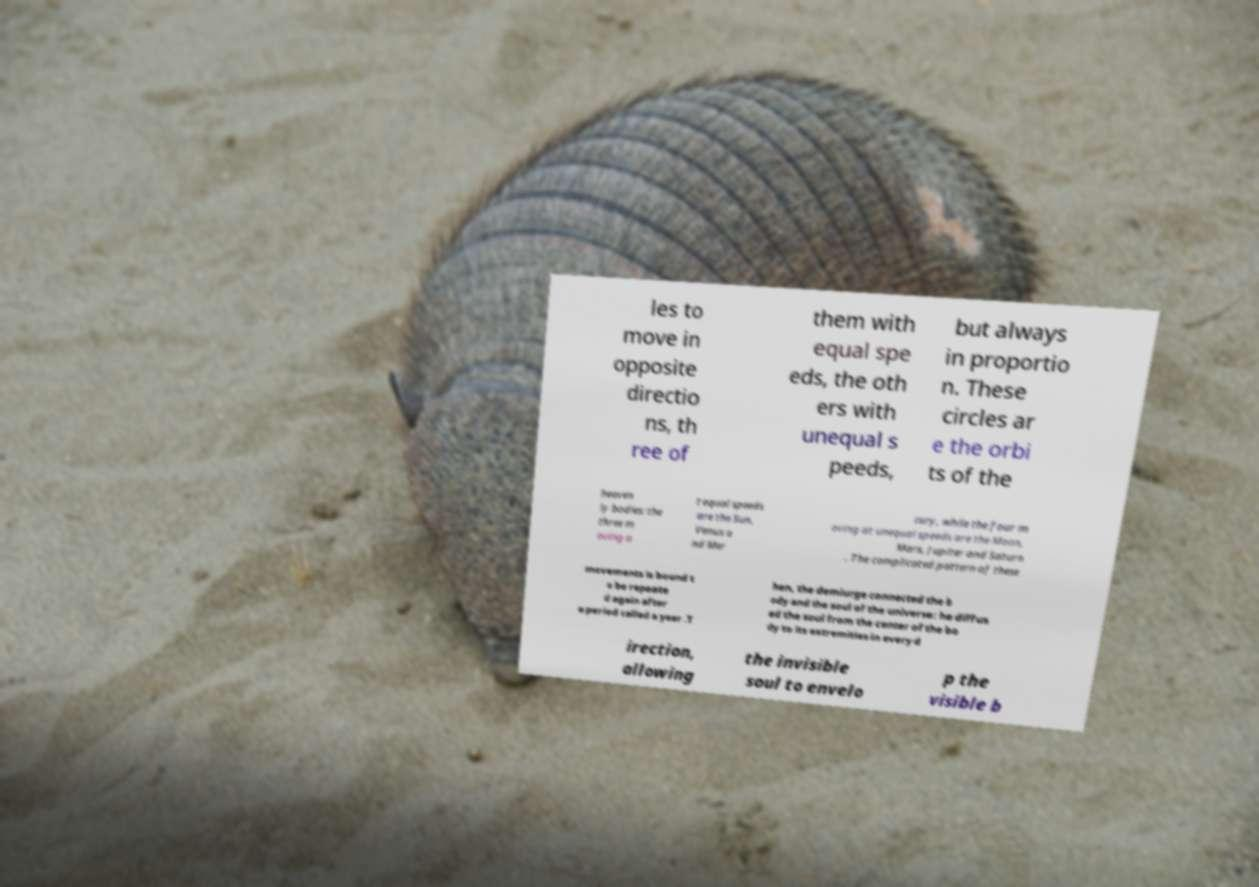Could you extract and type out the text from this image? les to move in opposite directio ns, th ree of them with equal spe eds, the oth ers with unequal s peeds, but always in proportio n. These circles ar e the orbi ts of the heaven ly bodies: the three m oving a t equal speeds are the Sun, Venus a nd Mer cury, while the four m oving at unequal speeds are the Moon, Mars, Jupiter and Saturn . The complicated pattern of these movements is bound t o be repeate d again after a period called a year .T hen, the demiurge connected the b ody and the soul of the universe: he diffus ed the soul from the center of the bo dy to its extremities in every d irection, allowing the invisible soul to envelo p the visible b 